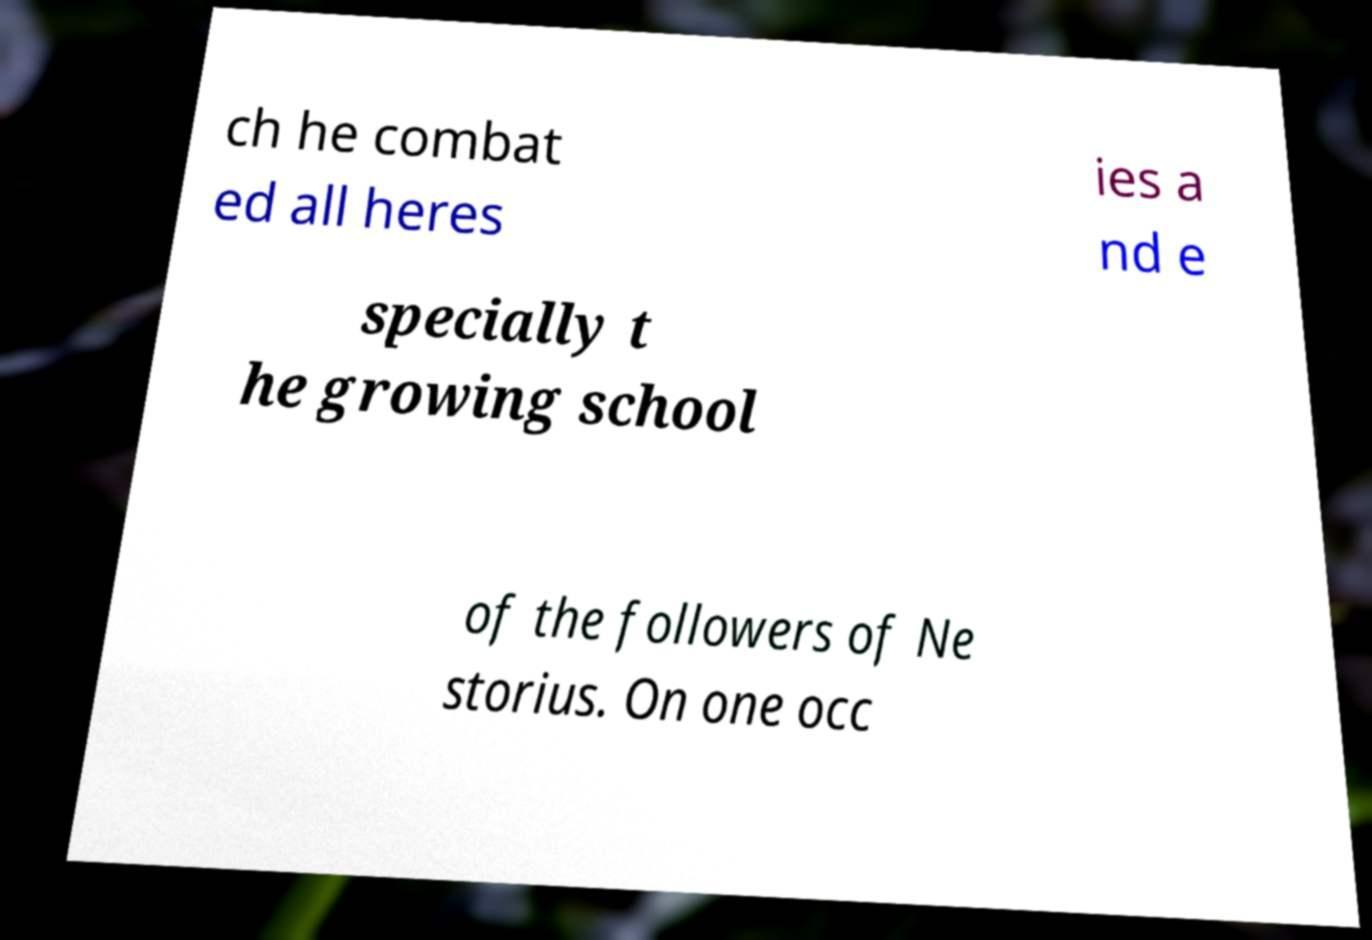Could you extract and type out the text from this image? ch he combat ed all heres ies a nd e specially t he growing school of the followers of Ne storius. On one occ 